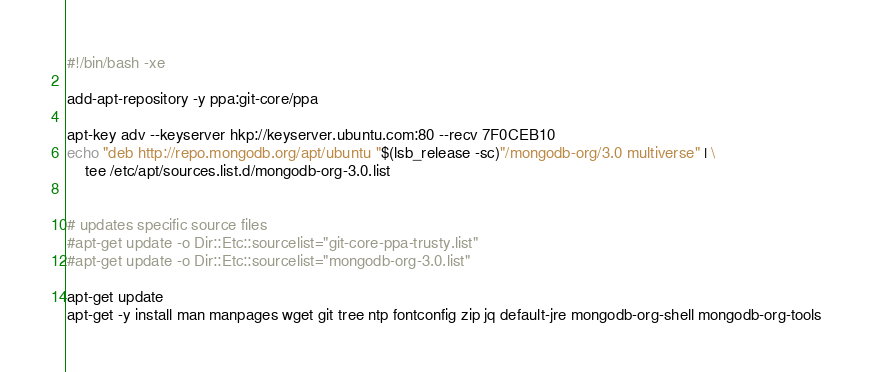Convert code to text. <code><loc_0><loc_0><loc_500><loc_500><_Bash_>#!/bin/bash -xe

add-apt-repository -y ppa:git-core/ppa

apt-key adv --keyserver hkp://keyserver.ubuntu.com:80 --recv 7F0CEB10
echo "deb http://repo.mongodb.org/apt/ubuntu "$(lsb_release -sc)"/mongodb-org/3.0 multiverse" | \
    tee /etc/apt/sources.list.d/mongodb-org-3.0.list


# updates specific source files
#apt-get update -o Dir::Etc::sourcelist="git-core-ppa-trusty.list"
#apt-get update -o Dir::Etc::sourcelist="mongodb-org-3.0.list"

apt-get update
apt-get -y install man manpages wget git tree ntp fontconfig zip jq default-jre mongodb-org-shell mongodb-org-tools
</code> 